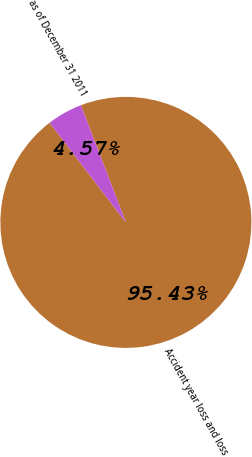Convert chart. <chart><loc_0><loc_0><loc_500><loc_500><pie_chart><fcel>Accident year loss and loss<fcel>as of December 31 2011<nl><fcel>95.43%<fcel>4.57%<nl></chart> 